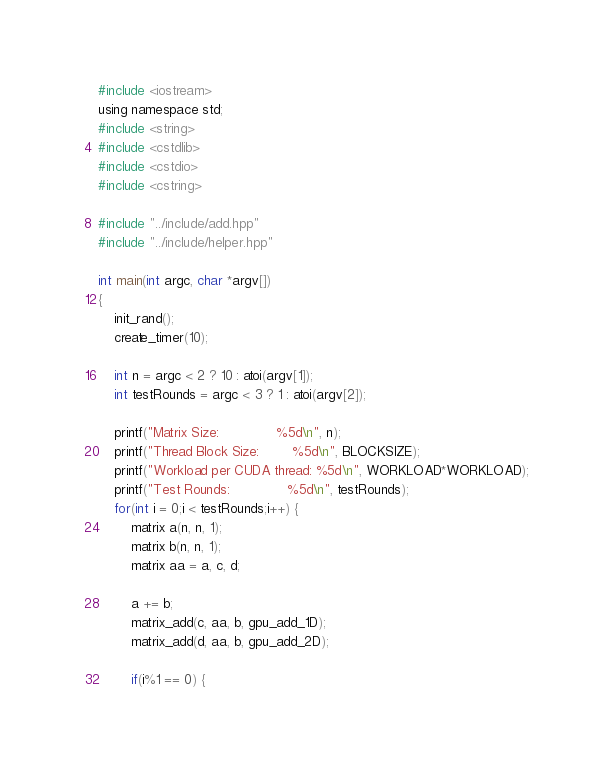<code> <loc_0><loc_0><loc_500><loc_500><_Cuda_>#include <iostream>
using namespace std;
#include <string>
#include <cstdlib>
#include <cstdio>
#include <cstring>

#include "../include/add.hpp"
#include "../include/helper.hpp"

int main(int argc, char *argv[])
{
    init_rand();
    create_timer(10);

    int n = argc < 2 ? 10 : atoi(argv[1]);
    int testRounds = argc < 3 ? 1 : atoi(argv[2]);
    
    printf("Matrix Size:              %5d\n", n);
    printf("Thread Block Size:        %5d\n", BLOCKSIZE);
    printf("Workload per CUDA thread: %5d\n", WORKLOAD*WORKLOAD);
    printf("Test Rounds:              %5d\n", testRounds);
    for(int i = 0;i < testRounds;i++) {
        matrix a(n, n, 1);
        matrix b(n, n, 1);
        matrix aa = a, c, d;

        a += b;
        matrix_add(c, aa, b, gpu_add_1D);
        matrix_add(d, aa, b, gpu_add_2D);

        if(i%1 == 0) {</code> 